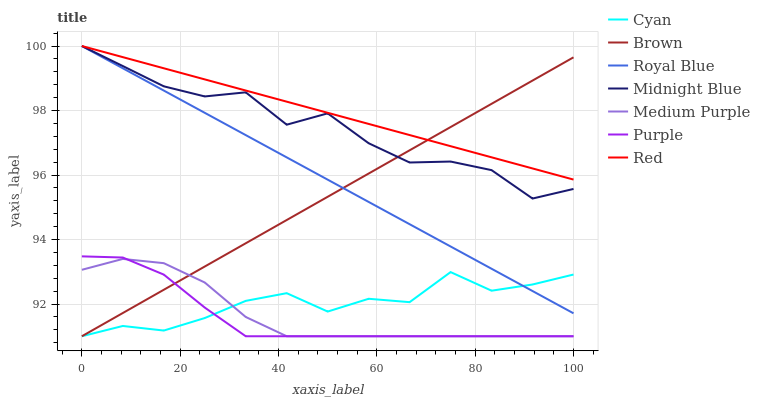Does Purple have the minimum area under the curve?
Answer yes or no. Yes. Does Red have the maximum area under the curve?
Answer yes or no. Yes. Does Midnight Blue have the minimum area under the curve?
Answer yes or no. No. Does Midnight Blue have the maximum area under the curve?
Answer yes or no. No. Is Brown the smoothest?
Answer yes or no. Yes. Is Midnight Blue the roughest?
Answer yes or no. Yes. Is Purple the smoothest?
Answer yes or no. No. Is Purple the roughest?
Answer yes or no. No. Does Brown have the lowest value?
Answer yes or no. Yes. Does Midnight Blue have the lowest value?
Answer yes or no. No. Does Red have the highest value?
Answer yes or no. Yes. Does Purple have the highest value?
Answer yes or no. No. Is Medium Purple less than Royal Blue?
Answer yes or no. Yes. Is Red greater than Cyan?
Answer yes or no. Yes. Does Royal Blue intersect Cyan?
Answer yes or no. Yes. Is Royal Blue less than Cyan?
Answer yes or no. No. Is Royal Blue greater than Cyan?
Answer yes or no. No. Does Medium Purple intersect Royal Blue?
Answer yes or no. No. 